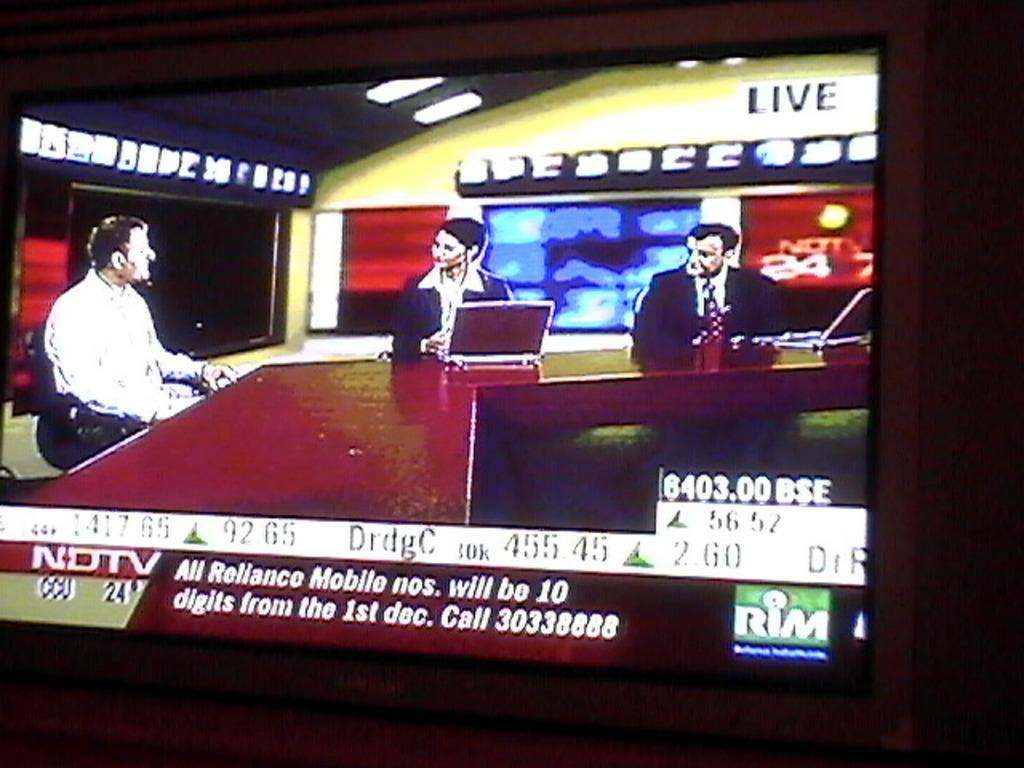Provide a one-sentence caption for the provided image. A shot of a tv with a news broadcast from NDTV on it. 